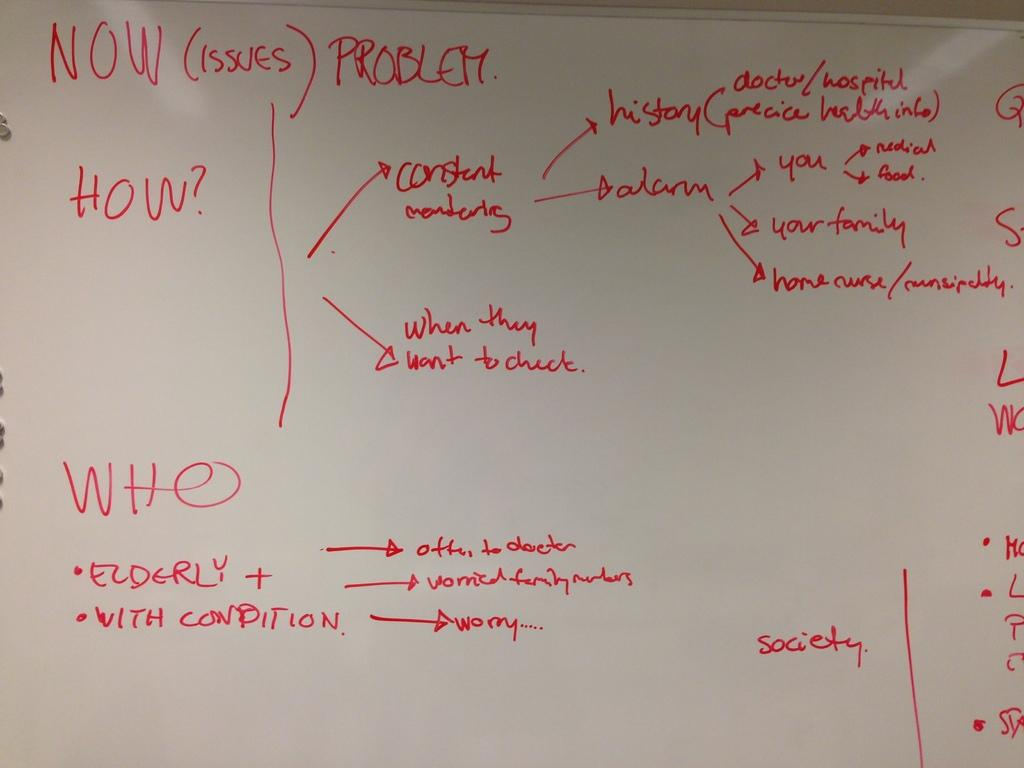<image>
Render a clear and concise summary of the photo. A white board with questions regarding elderly people under the headers of "NOW (Issues) Problem", "How?", and "Who". 